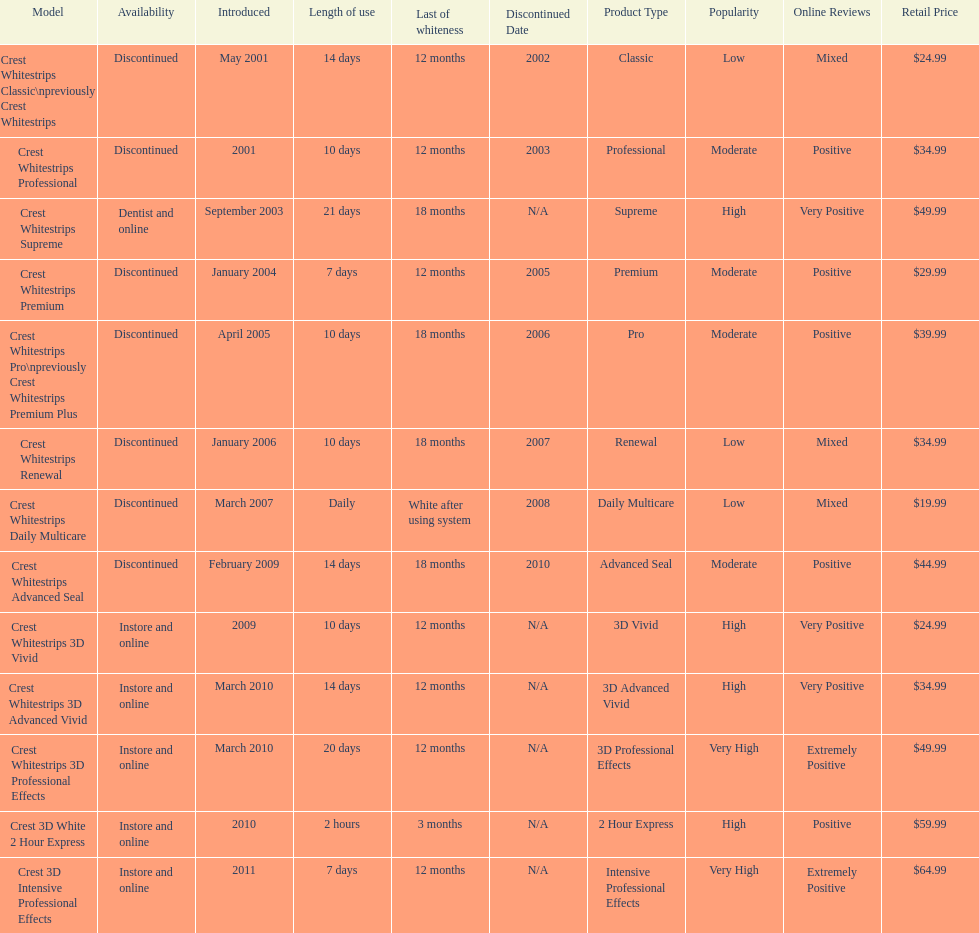What products are listed? Crest Whitestrips Classic\npreviously Crest Whitestrips, Crest Whitestrips Professional, Crest Whitestrips Supreme, Crest Whitestrips Premium, Crest Whitestrips Pro\npreviously Crest Whitestrips Premium Plus, Crest Whitestrips Renewal, Crest Whitestrips Daily Multicare, Crest Whitestrips Advanced Seal, Crest Whitestrips 3D Vivid, Crest Whitestrips 3D Advanced Vivid, Crest Whitestrips 3D Professional Effects, Crest 3D White 2 Hour Express, Crest 3D Intensive Professional Effects. Of these, which was were introduced in march, 2010? Crest Whitestrips 3D Advanced Vivid, Crest Whitestrips 3D Professional Effects. Of these, which were not 3d advanced vivid? Crest Whitestrips 3D Professional Effects. 